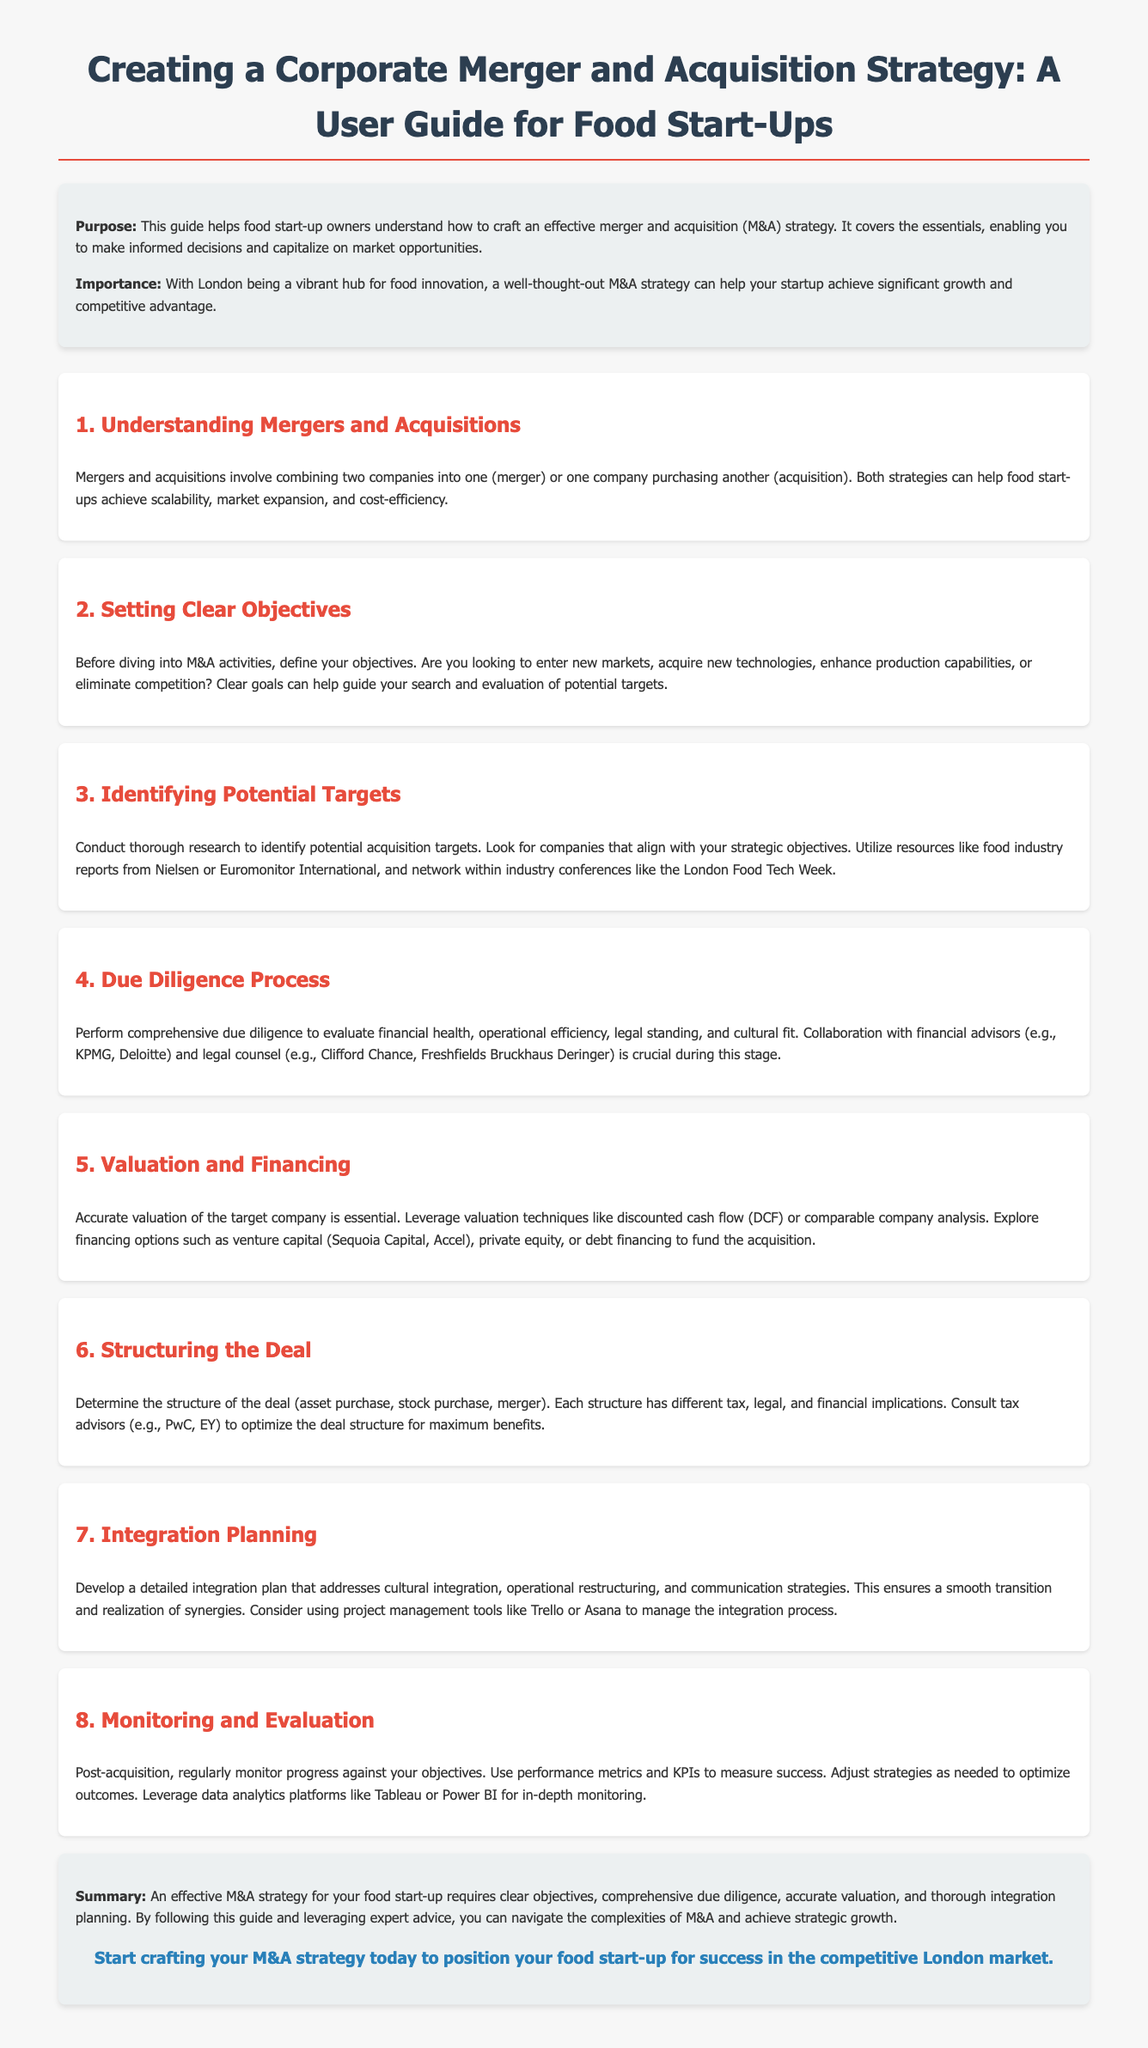What is the purpose of the guide? The purpose of the guide is to help food start-up owners understand how to craft an effective merger and acquisition (M&A) strategy.
Answer: To help food start-up owners understand how to craft an effective merger and acquisition (M&A) strategy What are Mergers and Acquisitions? Mergers and acquisitions involve combining two companies into one or one company purchasing another.
Answer: Combining two companies or one company purchasing another What should be defined before M&A activities? Before diving into M&A activities, clear objectives should be defined.
Answer: Clear objectives Which reports are recommended for identifying potential targets? Utilize resources like food industry reports from Nielsen or Euromonitor International.
Answer: Nielsen or Euromonitor International What is crucial during the due diligence process? Collaboration with financial advisors and legal counsel is crucial during the due diligence process.
Answer: Collaboration with advisors and counsel What financing options are suggested for funding acquisitions? Explore financing options such as venture capital, private equity, or debt financing.
Answer: Venture capital, private equity, or debt financing What type of plan should be developed post-acquisition? Develop a detailed integration plan that addresses cultural integration, operational restructuring, and communication strategies.
Answer: Detailed integration plan What tools can be used to manage the integration process? Consider using project management tools like Trello or Asana to manage the integration process.
Answer: Trello or Asana What is the focus of monitoring and evaluation post-acquisition? Regularly monitor progress against your objectives using performance metrics and KPIs.
Answer: Progress against objectives using metrics and KPIs 